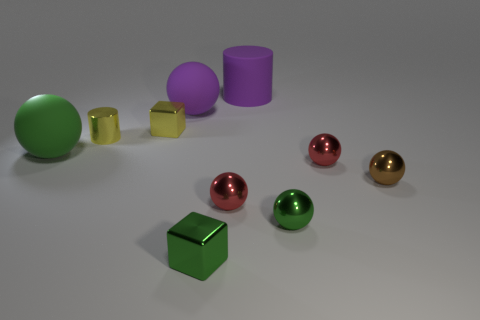Subtract 3 balls. How many balls are left? 3 Subtract all purple balls. How many balls are left? 5 Subtract all red spheres. How many spheres are left? 4 Subtract all purple spheres. Subtract all yellow cylinders. How many spheres are left? 5 Subtract all cylinders. How many objects are left? 8 Add 6 small cyan matte spheres. How many small cyan matte spheres exist? 6 Subtract 0 green cylinders. How many objects are left? 10 Subtract all metallic balls. Subtract all metallic cylinders. How many objects are left? 5 Add 2 large purple rubber balls. How many large purple rubber balls are left? 3 